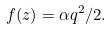Convert formula to latex. <formula><loc_0><loc_0><loc_500><loc_500>f ( z ) = \alpha q ^ { 2 } / 2 .</formula> 